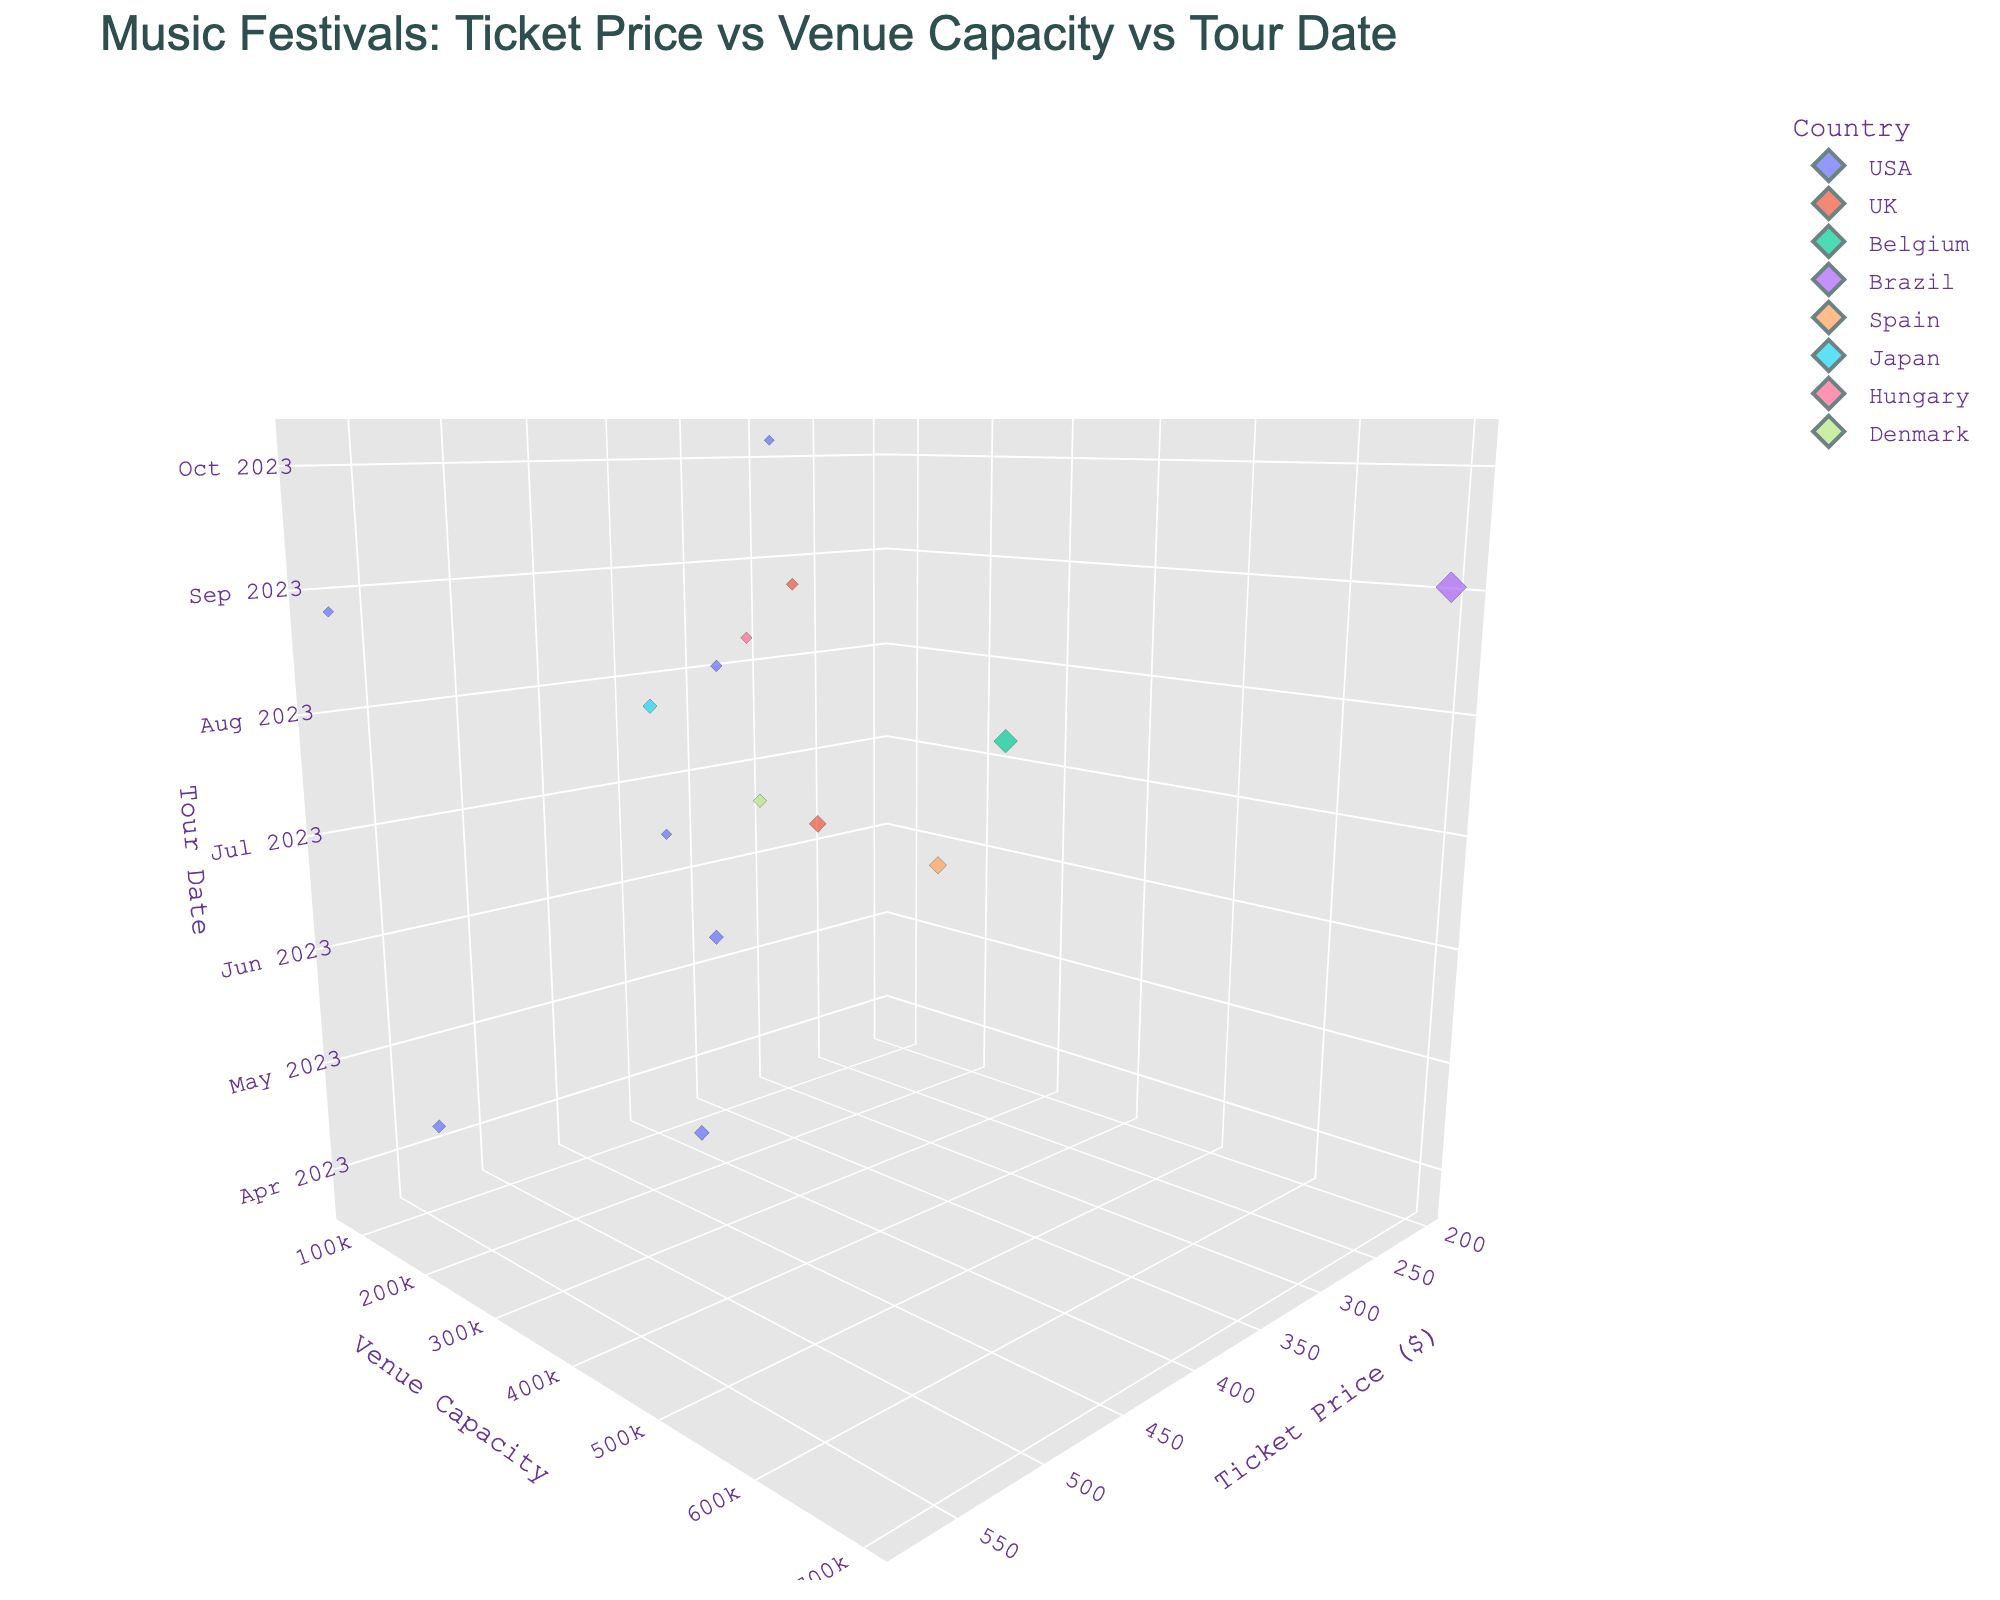How many festivals are from the USA? There are multiple data points for each festival, and the color coding will help identify those from the USA. Upon counting the data points with the USA color, there are 7 festivals.
Answer: 7 Which festival has the highest ticket price? Locate the data point with the highest value on the Ticket Price axis. The highest ticket price is $575 for Burning Man.
Answer: Burning Man Which country has the festival with the largest venue capacity? Identify the data point with the highest value on the Venue Capacity axis. The largest venue capacity is 700,000 for Rock in Rio in Brazil.
Answer: Brazil What is the average venue capacity of music festivals in the UK? There are 2 festivals in the UK: Glastonbury (210,000) and Reading Festival (105,000). (210,000 + 105,000) / 2 = 157,500.
Answer: 157,500 Which festival has the earliest tour date? Look at the lowest value on the Tour Date axis. The earliest tour date is March 24, 2023, for Ultra Music Festival.
Answer: Ultra Music Festival Which festival has the lowest ticket price and what is it? Locate the data point with the lowest value on the Ticket Price axis. The lowest ticket price is $200 for Rock in Rio.
Answer: Rock in Rio Is there any correlation between ticket prices and venue capacities for the festivals? By observing the 3D scatter plot, there does not seem to be a clear direct correlation between ticket prices and venue capacities. Data points are scattered without a clear pattern.
Answer: No clear correlation How many festivals in August have a ticket price greater than $300? Identify the data points in August and count those with ticket prices greater than $300. Lollapalooza ($350), Sziget ($325), Reading Festival ($295 - not greater), and Burning Man ($575). Only Lollapalooza, Sziget, and Burning Man fulfill both criteria.
Answer: 3 What is the ticket price range for festivals in the USA? Identify the highest and lowest ticket prices for festivals in the USA: Burning Man ($575) and Lollapalooza ($350). Range = $575 - $350 = $225.
Answer: $225 Which festival has the smallest venue capacity, and what is that capacity? Identify the data point with the smallest value on the Venue Capacity axis. The smallest venue capacity is 75,000 for Austin City Limits.
Answer: Austin City Limits 